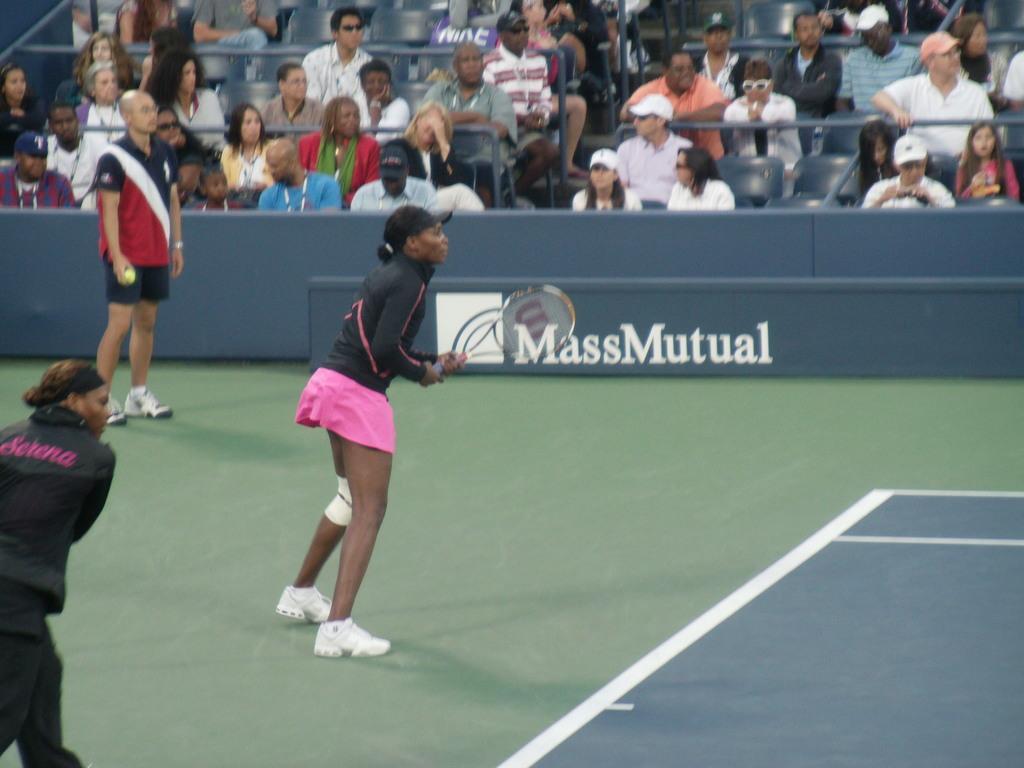Describe this image in one or two sentences. here we can see a woman is standing on the floor and holding a racket in her hands, and at back the group of people are sitting on the chair. 